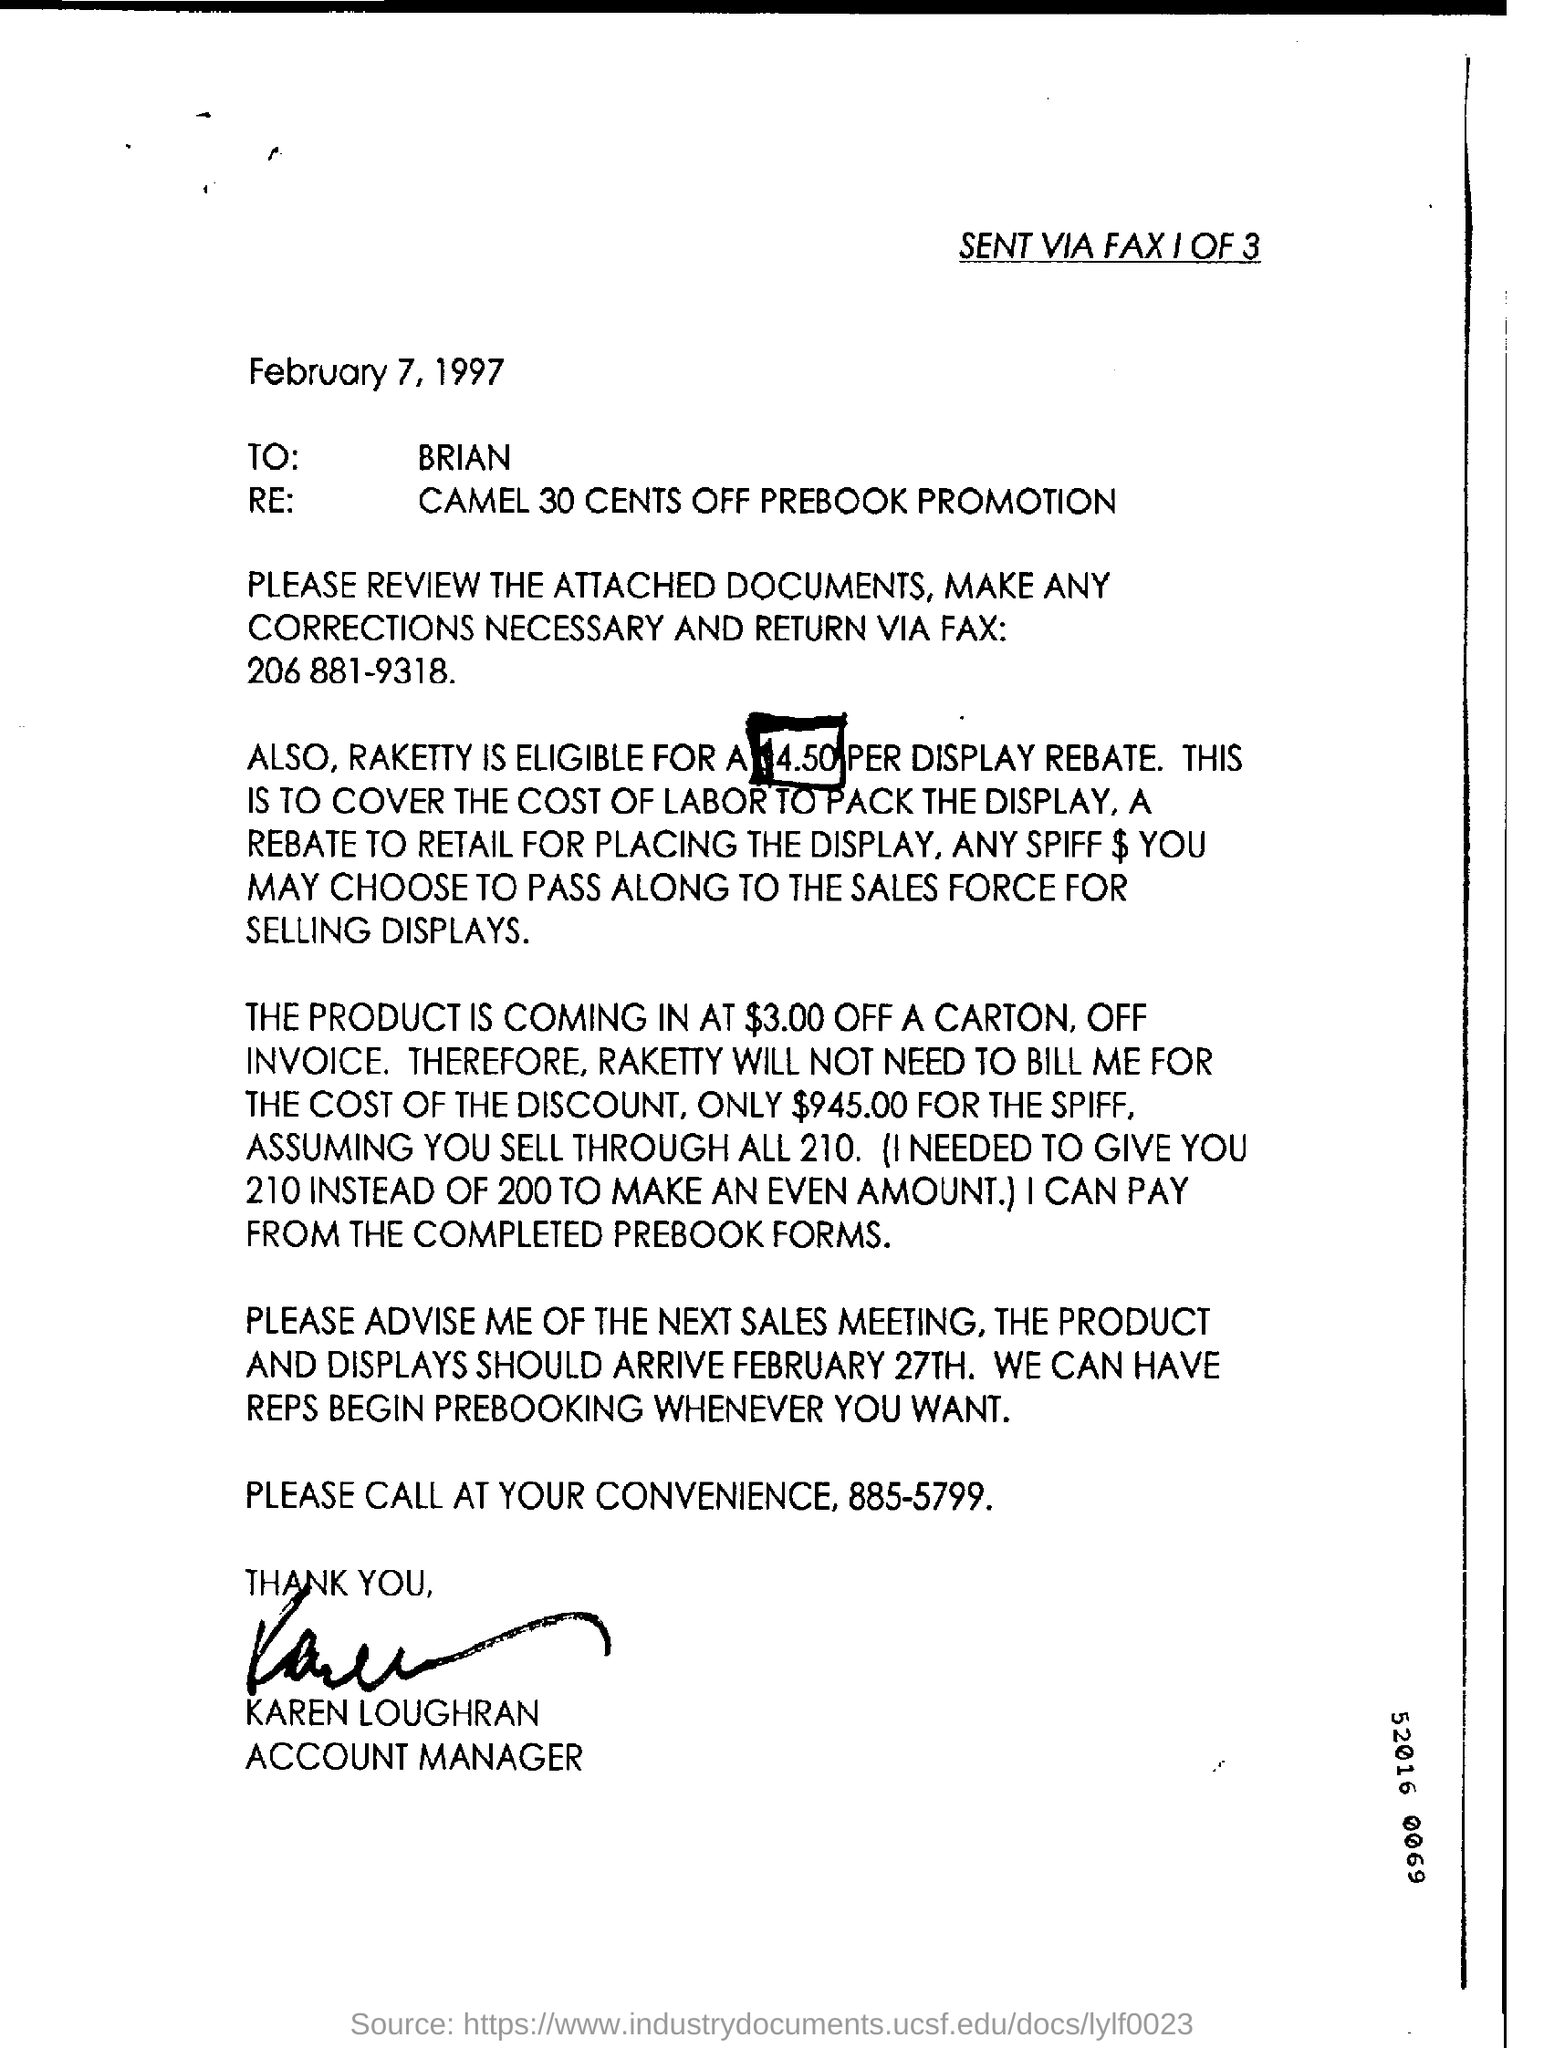Outline some significant characteristics in this image. The document informs that the date mentioned in it is February 7, 1997. The fax number in the document is 206 881-9318. 